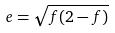Convert formula to latex. <formula><loc_0><loc_0><loc_500><loc_500>e = \sqrt { f ( 2 - f ) }</formula> 